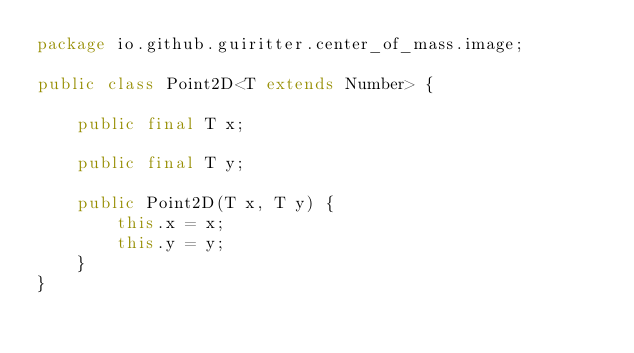<code> <loc_0><loc_0><loc_500><loc_500><_Java_>package io.github.guiritter.center_of_mass.image;

public class Point2D<T extends Number> {

	public final T x;

	public final T y;

	public Point2D(T x, T y) {
		this.x = x;
		this.y = y;
	}
}
</code> 